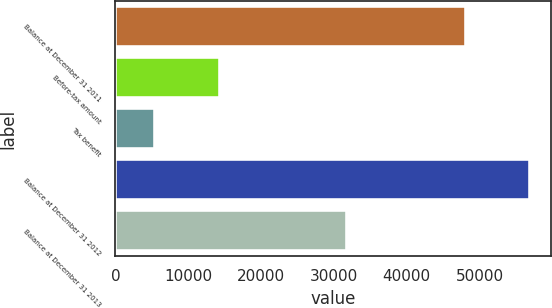<chart> <loc_0><loc_0><loc_500><loc_500><bar_chart><fcel>Balance at December 31 2011<fcel>Before-tax amount<fcel>Tax benefit<fcel>Balance at December 31 2012<fcel>Balance at December 31 2013<nl><fcel>48090<fcel>14323<fcel>5446<fcel>56967<fcel>31771<nl></chart> 